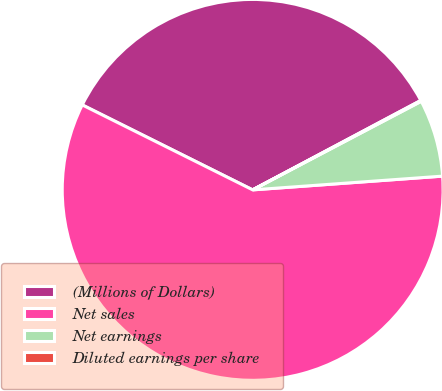Convert chart. <chart><loc_0><loc_0><loc_500><loc_500><pie_chart><fcel>(Millions of Dollars)<fcel>Net sales<fcel>Net earnings<fcel>Diluted earnings per share<nl><fcel>34.86%<fcel>58.51%<fcel>6.55%<fcel>0.08%<nl></chart> 